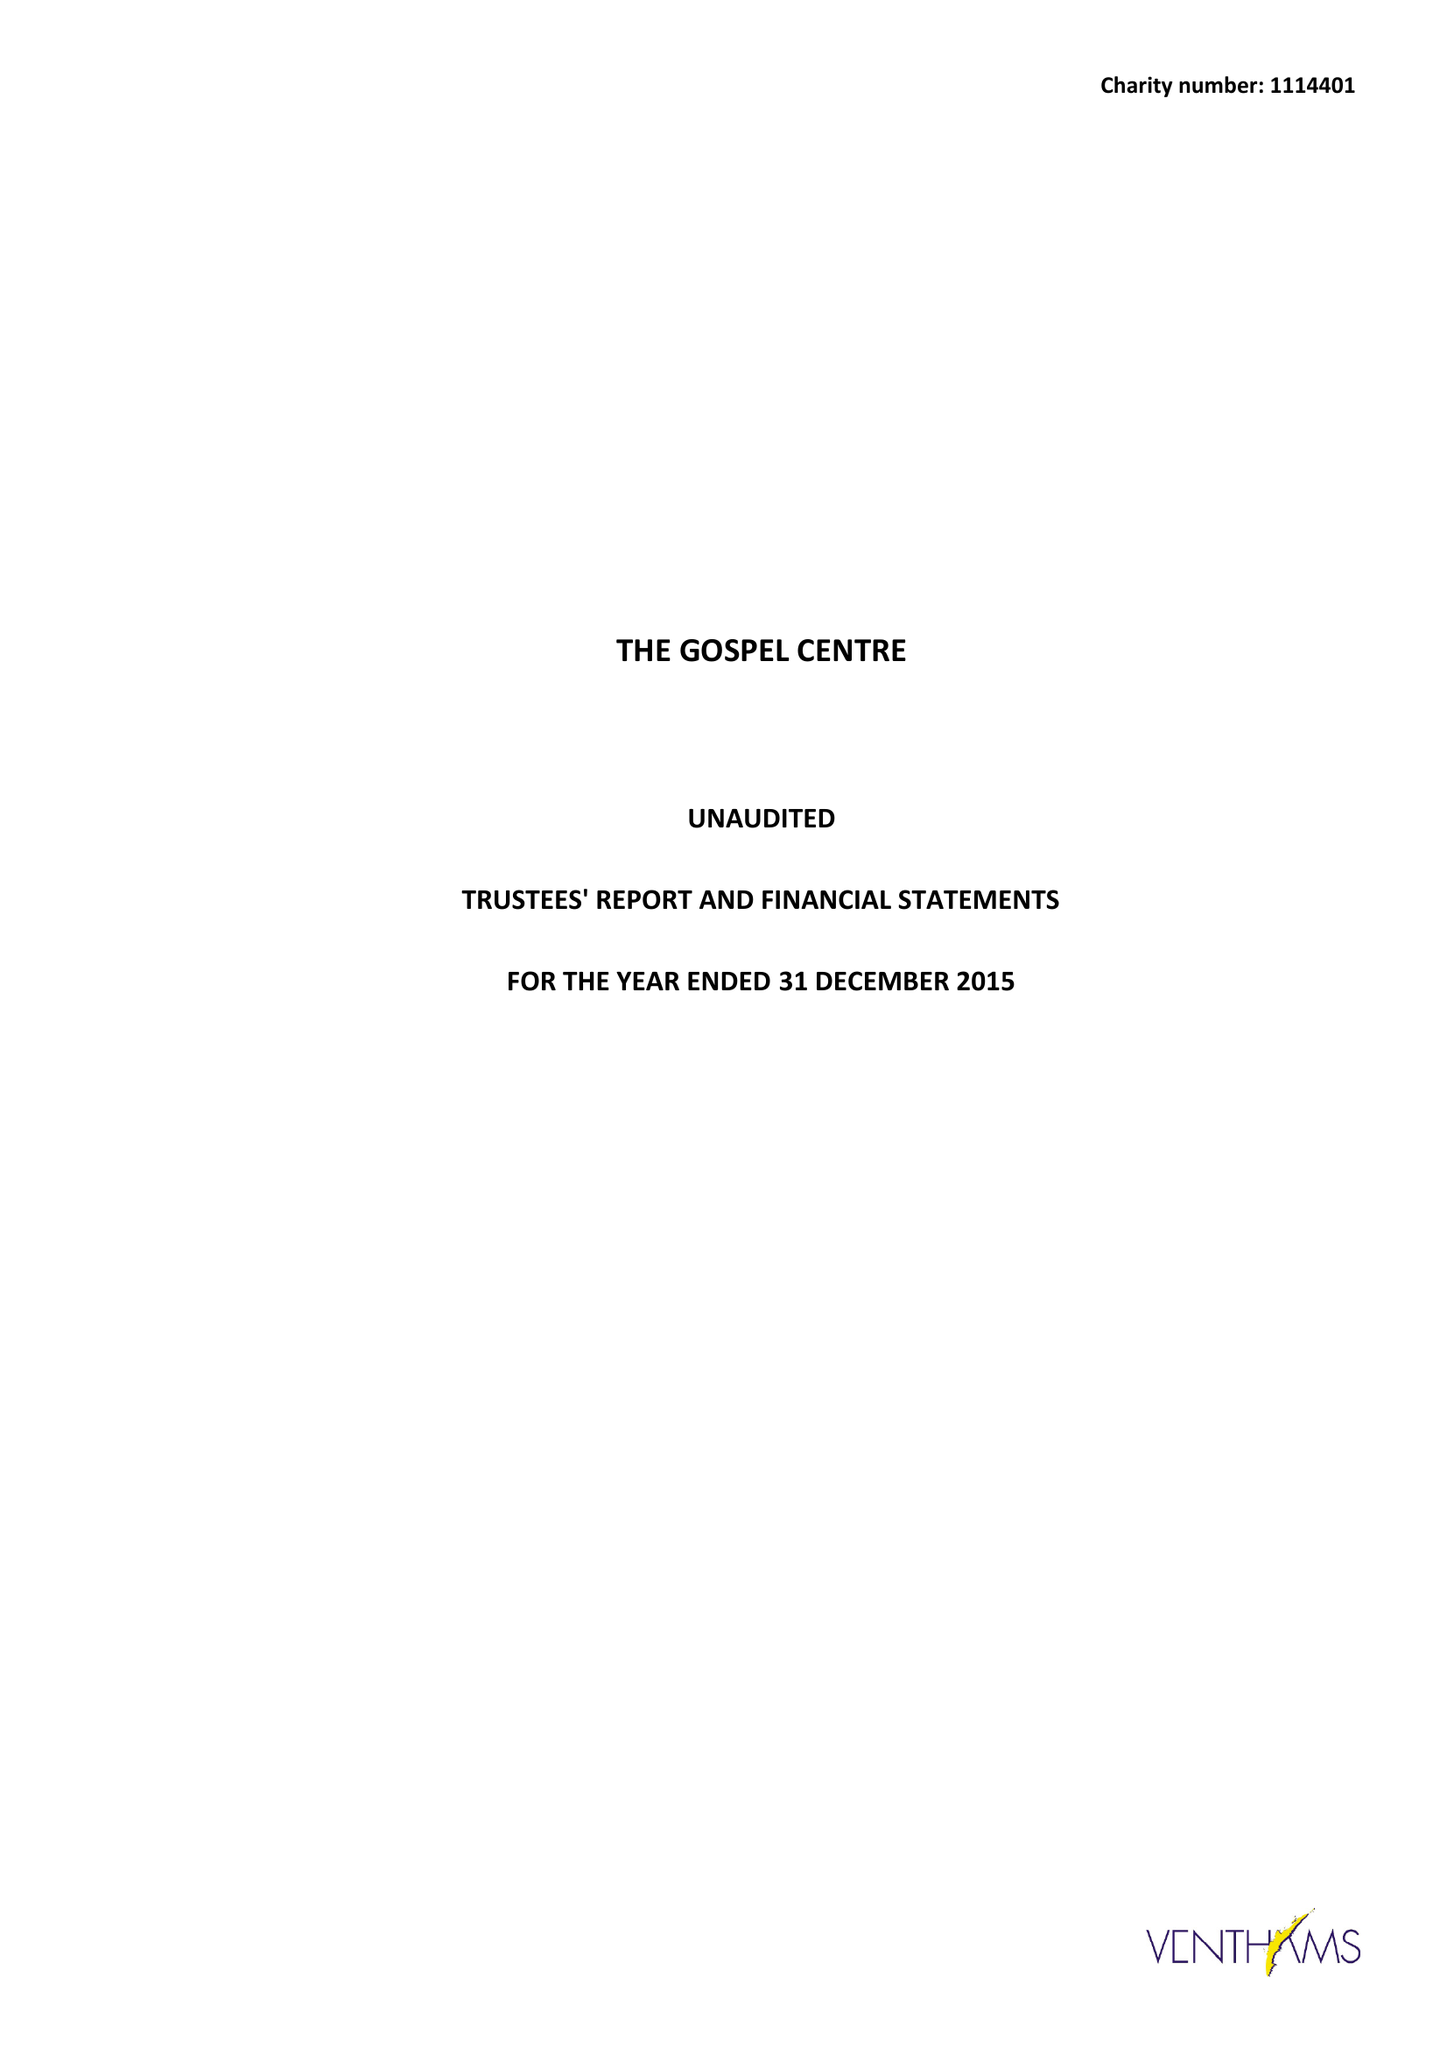What is the value for the report_date?
Answer the question using a single word or phrase. 2015-12-31 